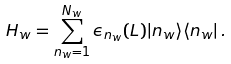<formula> <loc_0><loc_0><loc_500><loc_500>H _ { w } = \sum _ { n _ { w } = 1 } ^ { N _ { w } } \epsilon _ { n _ { w } } ( L ) | n _ { w } \rangle \langle n _ { w } | \, .</formula> 